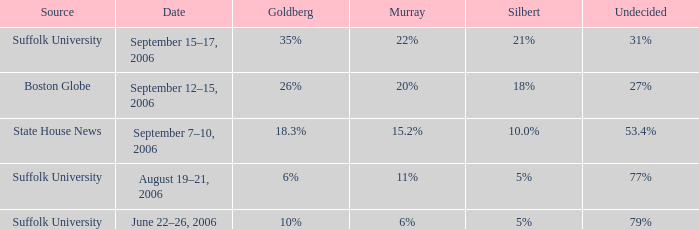What is the undecided percentage of the poll where Goldberg had 6%? 77%. 